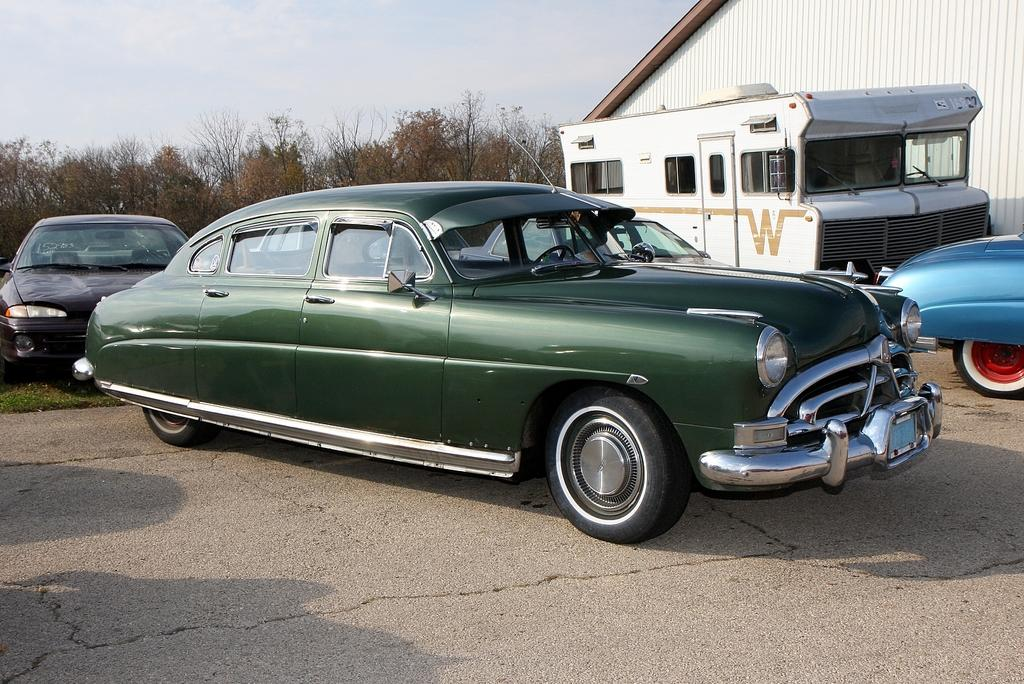How many vehicles are present in the image? There are three cars and a bus in the image, making a total of four vehicles. What are the vehicles doing in the image? The cars and bus are parked on a surface. What can be seen in the background of the image? There are trees and the sky visible in the background of the image. What type of polish is being applied to the top of the bucket in the image? There is no bucket or polish present in the image. 